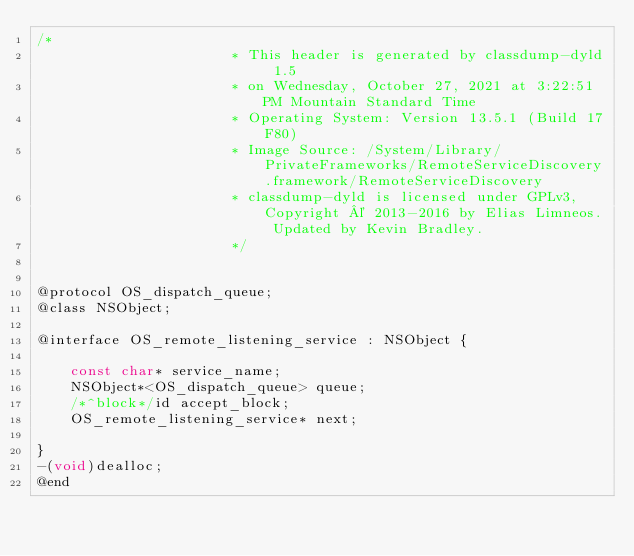<code> <loc_0><loc_0><loc_500><loc_500><_C_>/*
                       * This header is generated by classdump-dyld 1.5
                       * on Wednesday, October 27, 2021 at 3:22:51 PM Mountain Standard Time
                       * Operating System: Version 13.5.1 (Build 17F80)
                       * Image Source: /System/Library/PrivateFrameworks/RemoteServiceDiscovery.framework/RemoteServiceDiscovery
                       * classdump-dyld is licensed under GPLv3, Copyright © 2013-2016 by Elias Limneos. Updated by Kevin Bradley.
                       */


@protocol OS_dispatch_queue;
@class NSObject;

@interface OS_remote_listening_service : NSObject {

	const char* service_name;
	NSObject*<OS_dispatch_queue> queue;
	/*^block*/id accept_block;
	OS_remote_listening_service* next;

}
-(void)dealloc;
@end

</code> 